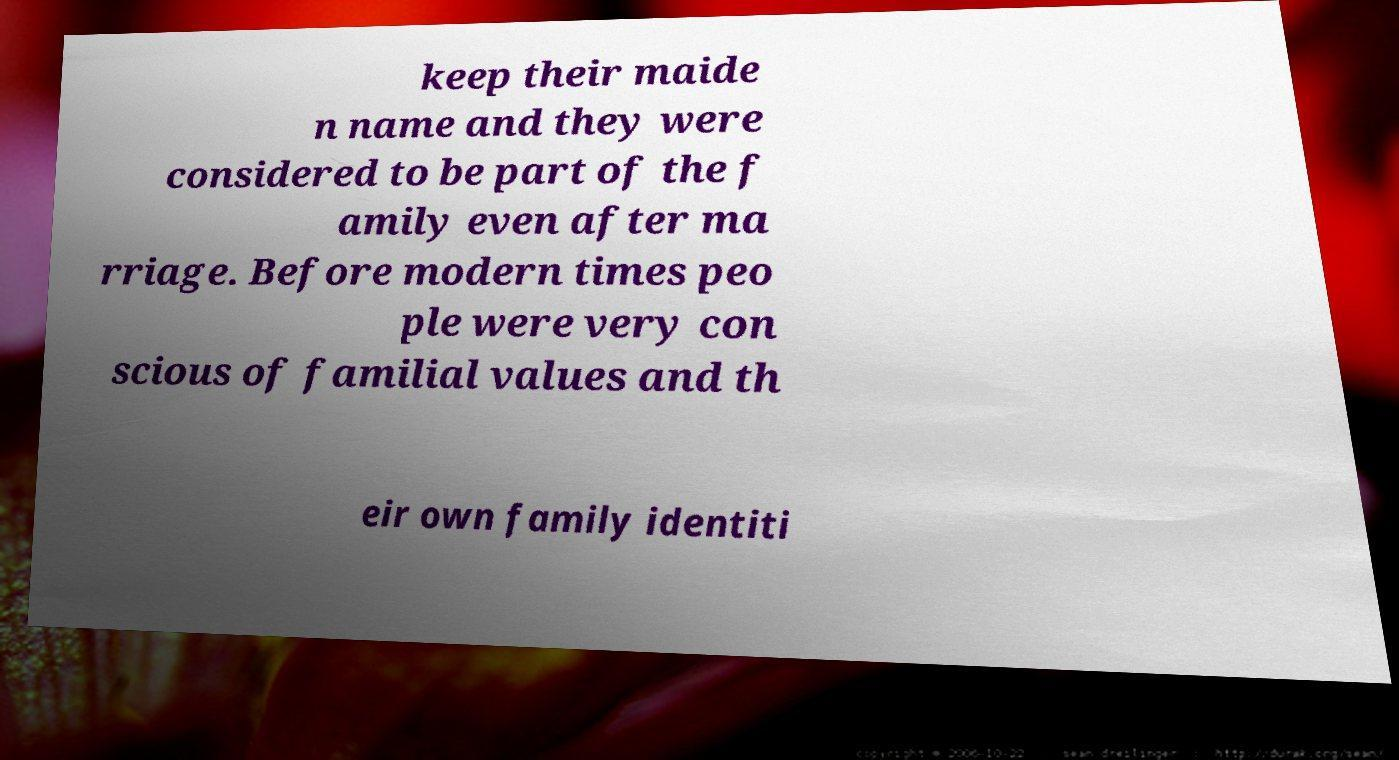Can you read and provide the text displayed in the image?This photo seems to have some interesting text. Can you extract and type it out for me? keep their maide n name and they were considered to be part of the f amily even after ma rriage. Before modern times peo ple were very con scious of familial values and th eir own family identiti 